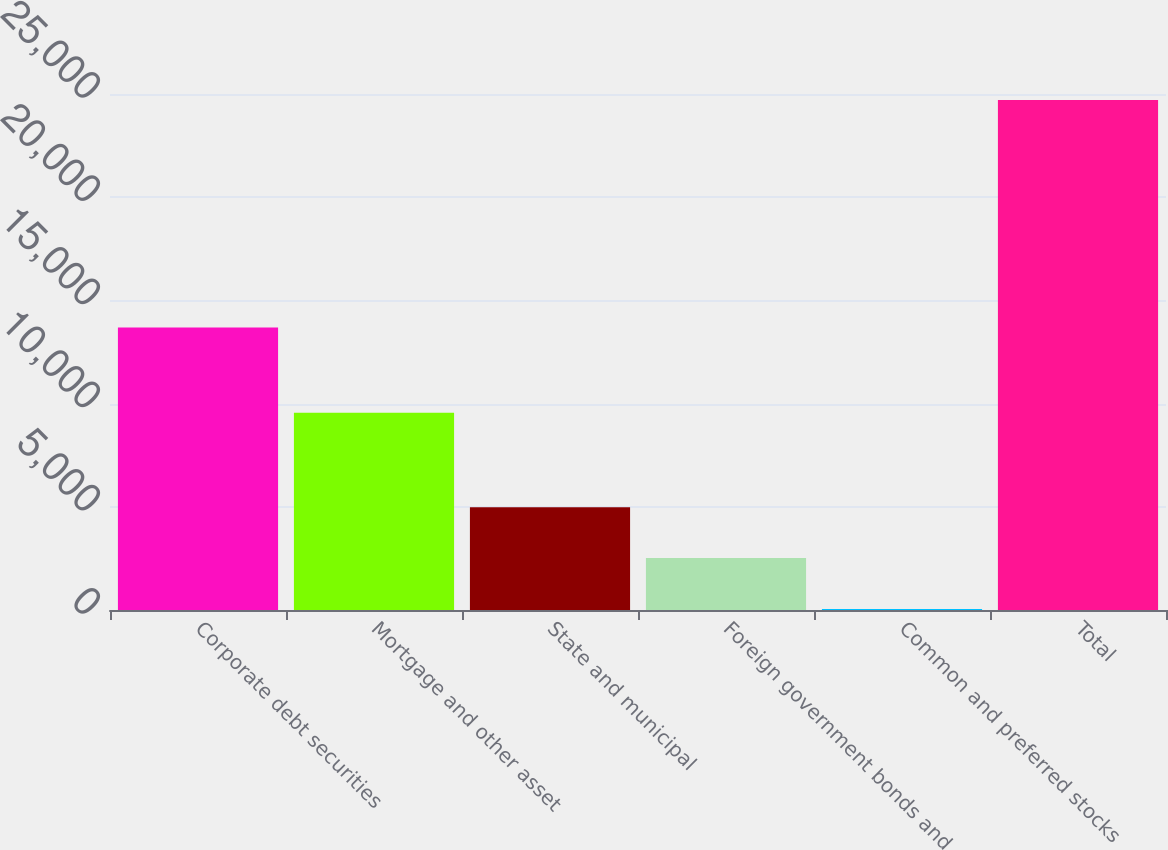<chart> <loc_0><loc_0><loc_500><loc_500><bar_chart><fcel>Corporate debt securities<fcel>Mortgage and other asset<fcel>State and municipal<fcel>Foreign government bonds and<fcel>Common and preferred stocks<fcel>Total<nl><fcel>13687<fcel>9551<fcel>4984<fcel>2518.5<fcel>53<fcel>24708<nl></chart> 